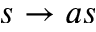Convert formula to latex. <formula><loc_0><loc_0><loc_500><loc_500>s \rightarrow a s</formula> 